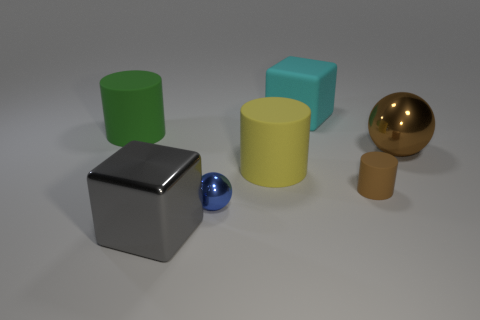Subtract all gray balls. Subtract all yellow cubes. How many balls are left? 2 Subtract all green cubes. How many red balls are left? 0 Add 7 large reds. How many greens exist? 0 Subtract all purple matte balls. Subtract all yellow rubber cylinders. How many objects are left? 6 Add 5 brown matte objects. How many brown matte objects are left? 6 Add 3 green objects. How many green objects exist? 4 Add 1 rubber cylinders. How many objects exist? 8 Subtract all brown cylinders. How many cylinders are left? 2 Subtract all yellow rubber cylinders. How many cylinders are left? 2 Subtract 0 cyan cylinders. How many objects are left? 7 